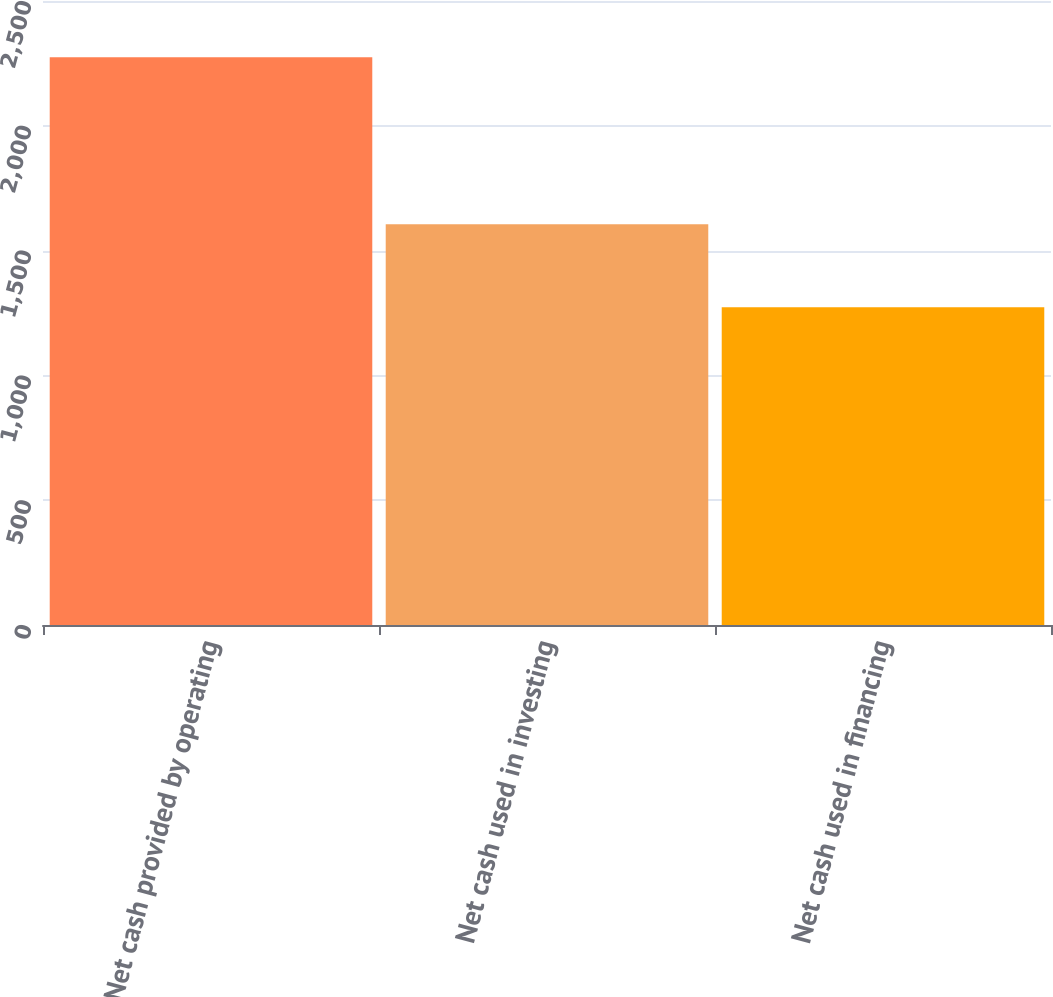<chart> <loc_0><loc_0><loc_500><loc_500><bar_chart><fcel>Net cash provided by operating<fcel>Net cash used in investing<fcel>Net cash used in financing<nl><fcel>2275<fcel>1606<fcel>1273<nl></chart> 